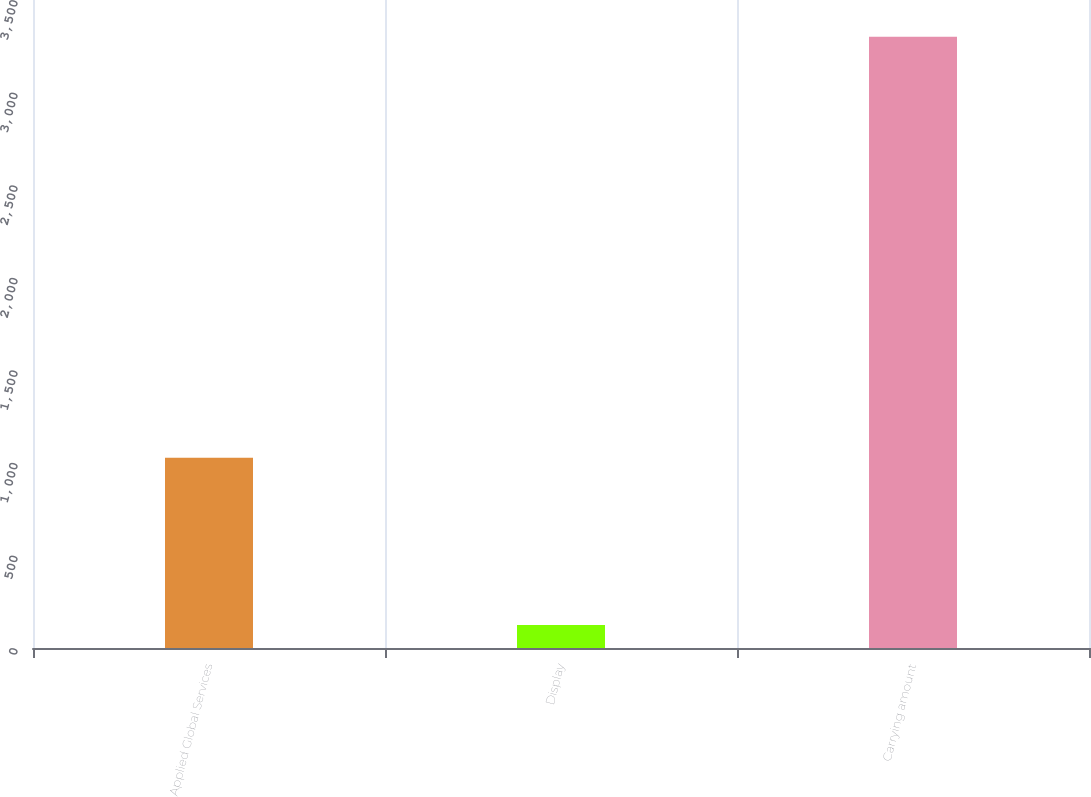Convert chart to OTSL. <chart><loc_0><loc_0><loc_500><loc_500><bar_chart><fcel>Applied Global Services<fcel>Display<fcel>Carrying amount<nl><fcel>1027<fcel>124<fcel>3302<nl></chart> 